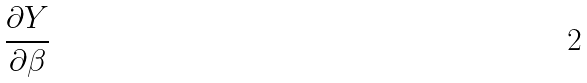Convert formula to latex. <formula><loc_0><loc_0><loc_500><loc_500>\frac { \partial Y } { \partial \beta }</formula> 